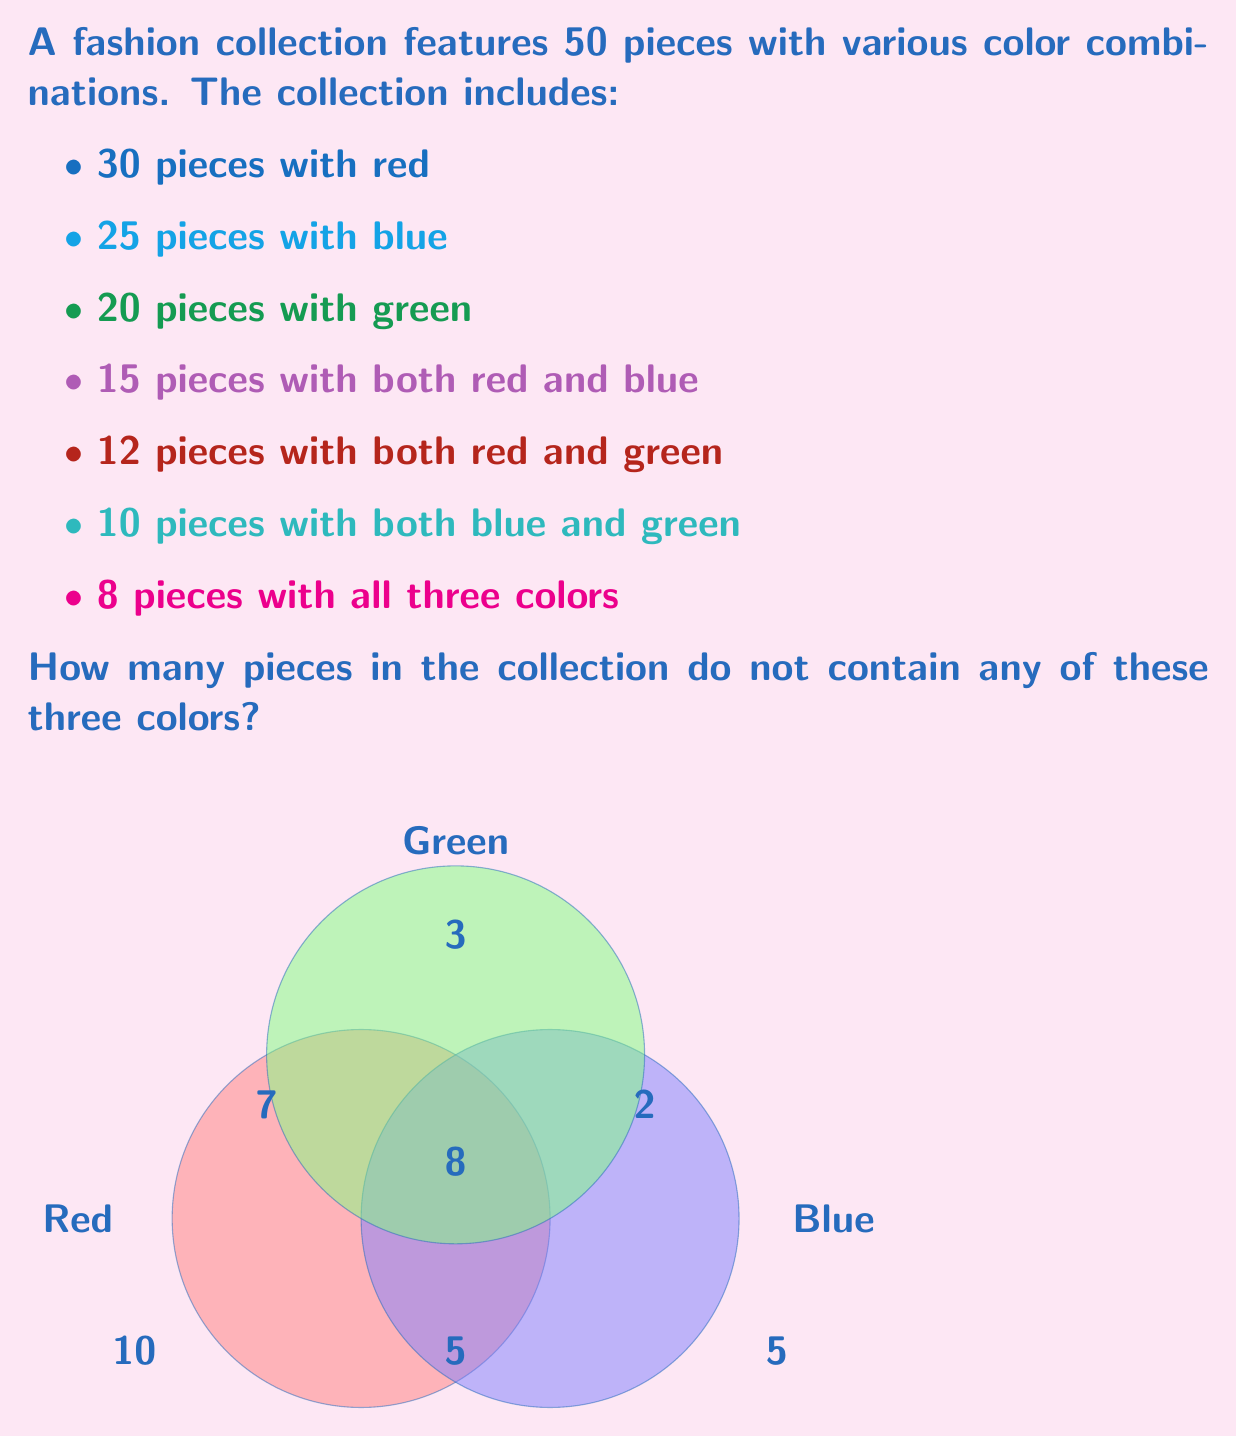Teach me how to tackle this problem. Let's approach this using set theory and the principle of inclusion-exclusion:

1) Let R, B, and G represent the sets of pieces containing red, blue, and green respectively.

2) We're given:
   $|R| = 30$, $|B| = 25$, $|G| = 20$
   $|R \cap B| = 15$, $|R \cap G| = 12$, $|B \cap G| = 10$
   $|R \cap B \cap G| = 8$

3) The total number of pieces with at least one of these colors is:

   $|R \cup B \cup G| = |R| + |B| + |G| - |R \cap B| - |R \cap G| - |B \cap G| + |R \cap B \cap G|$

4) Substituting the values:

   $|R \cup B \cup G| = 30 + 25 + 20 - 15 - 12 - 10 + 8 = 46$

5) The total number of pieces in the collection is 50.

6) Therefore, the number of pieces without any of these colors is:

   $50 - 46 = 4$
Answer: 4 pieces 